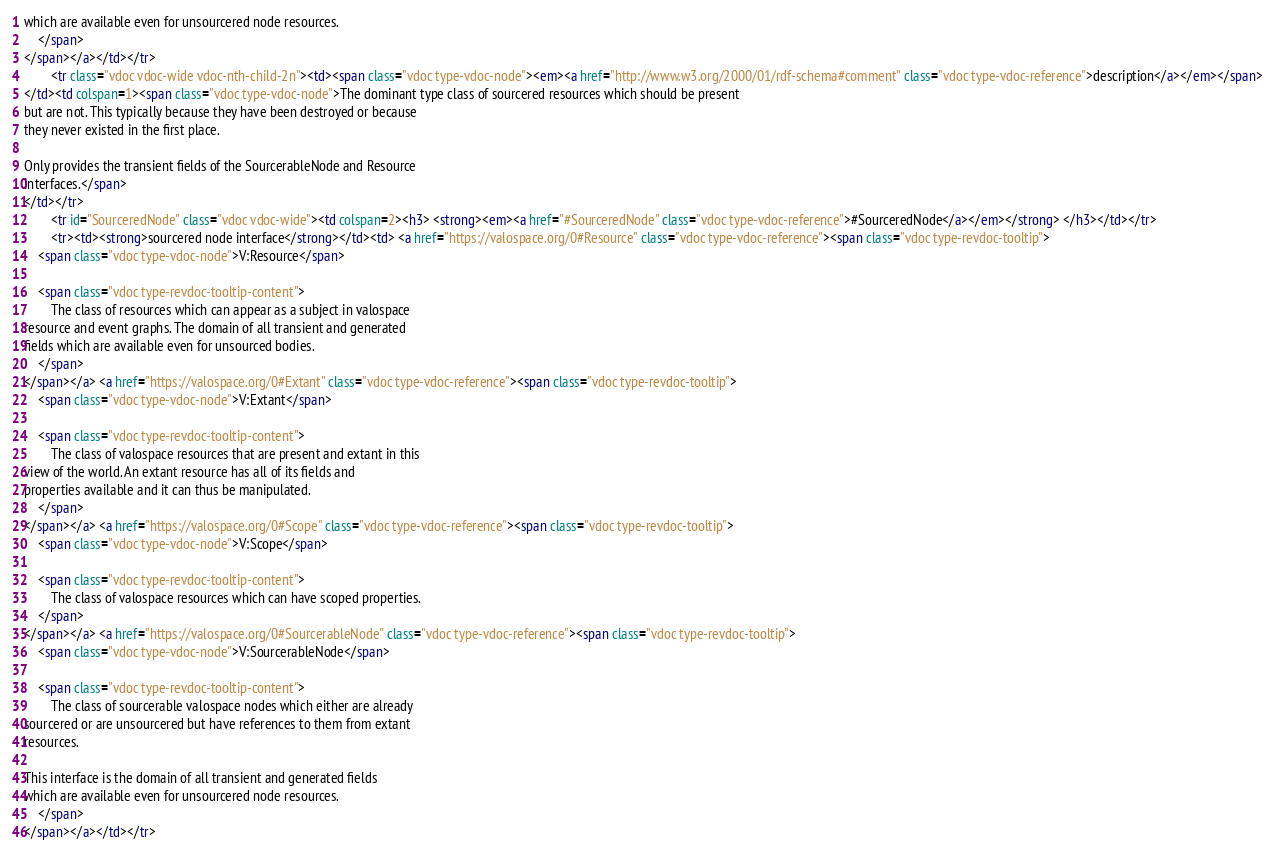Convert code to text. <code><loc_0><loc_0><loc_500><loc_500><_HTML_>which are available even for unsourcered node resources.
    </span>
</span></a></td></tr>
        <tr class="vdoc vdoc-wide vdoc-nth-child-2n"><td><span class="vdoc type-vdoc-node"><em><a href="http://www.w3.org/2000/01/rdf-schema#comment" class="vdoc type-vdoc-reference">description</a></em></span>
</td><td colspan=1><span class="vdoc type-vdoc-node">The dominant type class of sourcered resources which should be present
but are not. This typically because they have been destroyed or because
they never existed in the first place.

Only provides the transient fields of the SourcerableNode and Resource
interfaces.</span>
</td></tr>
        <tr id="SourceredNode" class="vdoc vdoc-wide"><td colspan=2><h3> <strong><em><a href="#SourceredNode" class="vdoc type-vdoc-reference">#SourceredNode</a></em></strong> </h3></td></tr>
        <tr><td><strong>sourcered node interface</strong></td><td> <a href="https://valospace.org/0#Resource" class="vdoc type-vdoc-reference"><span class="vdoc type-revdoc-tooltip">
    <span class="vdoc type-vdoc-node">V:Resource</span>

    <span class="vdoc type-revdoc-tooltip-content">
        The class of resources which can appear as a subject in valospace
resource and event graphs. The domain of all transient and generated
fields which are available even for unsourced bodies.
    </span>
</span></a> <a href="https://valospace.org/0#Extant" class="vdoc type-vdoc-reference"><span class="vdoc type-revdoc-tooltip">
    <span class="vdoc type-vdoc-node">V:Extant</span>

    <span class="vdoc type-revdoc-tooltip-content">
        The class of valospace resources that are present and extant in this
view of the world. An extant resource has all of its fields and
properties available and it can thus be manipulated.
    </span>
</span></a> <a href="https://valospace.org/0#Scope" class="vdoc type-vdoc-reference"><span class="vdoc type-revdoc-tooltip">
    <span class="vdoc type-vdoc-node">V:Scope</span>

    <span class="vdoc type-revdoc-tooltip-content">
        The class of valospace resources which can have scoped properties.
    </span>
</span></a> <a href="https://valospace.org/0#SourcerableNode" class="vdoc type-vdoc-reference"><span class="vdoc type-revdoc-tooltip">
    <span class="vdoc type-vdoc-node">V:SourcerableNode</span>

    <span class="vdoc type-revdoc-tooltip-content">
        The class of sourcerable valospace nodes which either are already
sourcered or are unsourcered but have references to them from extant
resources.

This interface is the domain of all transient and generated fields
which are available even for unsourcered node resources.
    </span>
</span></a></td></tr></code> 